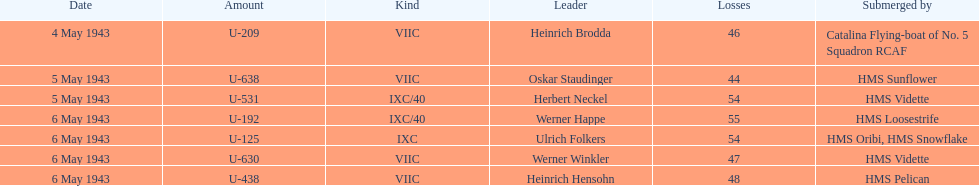What is the only vessel to sink multiple u-boats? HMS Vidette. 